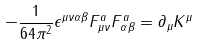Convert formula to latex. <formula><loc_0><loc_0><loc_500><loc_500>- \frac { 1 } { 6 4 \pi ^ { 2 } } \epsilon ^ { \mu \nu \alpha \beta } F ^ { a } _ { \mu \nu } F ^ { a } _ { \alpha \beta } = \partial _ { \mu } K ^ { \mu }</formula> 